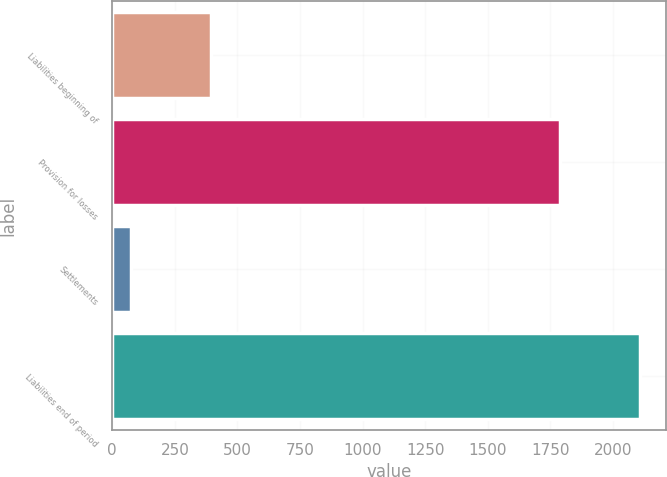<chart> <loc_0><loc_0><loc_500><loc_500><bar_chart><fcel>Liabilities beginning of<fcel>Provision for losses<fcel>Settlements<fcel>Liabilities end of period<nl><fcel>395<fcel>1787<fcel>75<fcel>2107<nl></chart> 